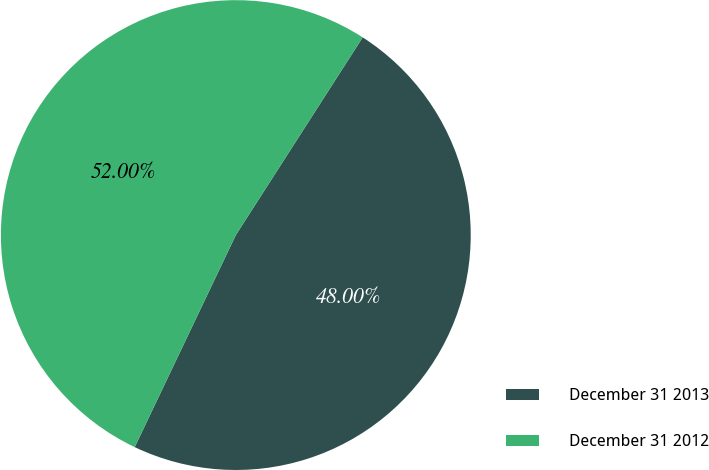Convert chart to OTSL. <chart><loc_0><loc_0><loc_500><loc_500><pie_chart><fcel>December 31 2013<fcel>December 31 2012<nl><fcel>48.0%<fcel>52.0%<nl></chart> 